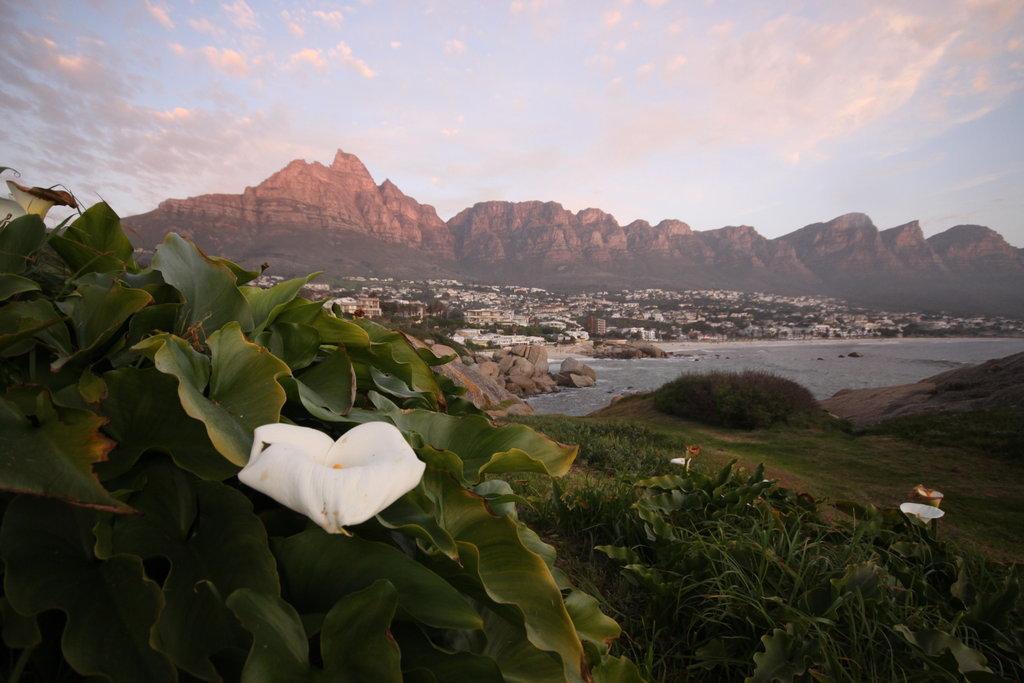How would you summarize this image in a sentence or two? Sky is cloudy. Background there are mountains. Far there are a number of buildings. Here we can see plants with flowers, grass and water.  